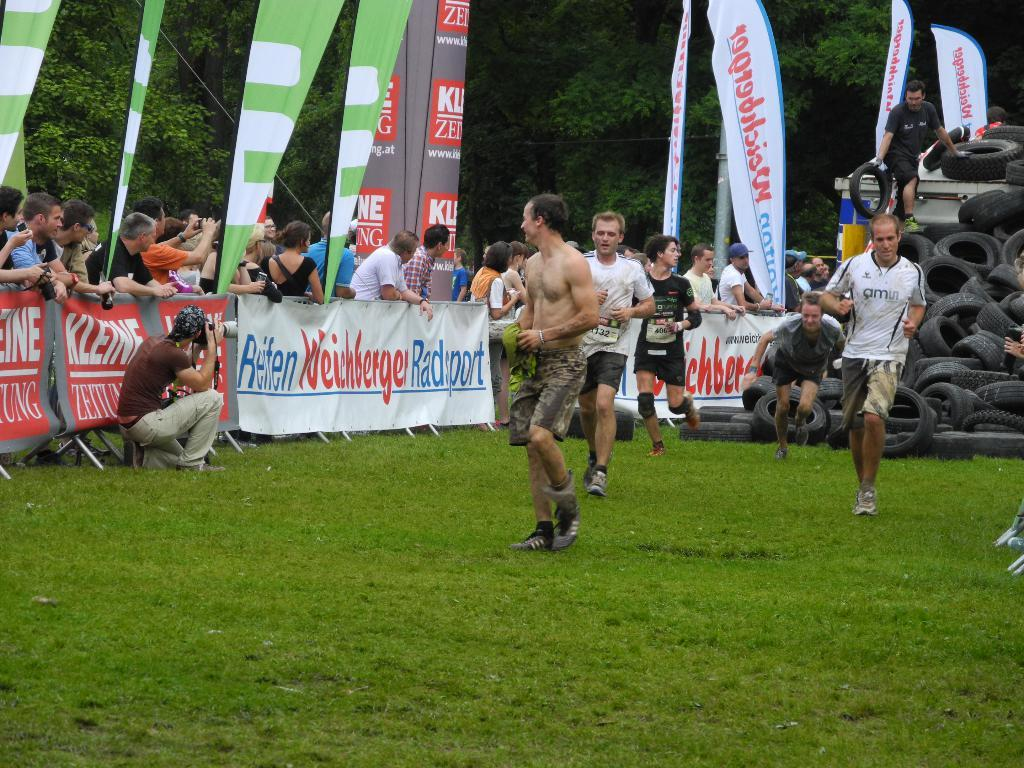Provide a one-sentence caption for the provided image. Players participating in an athletic competition with a banner on the wall that reads Reten Weinberger Radsport. 